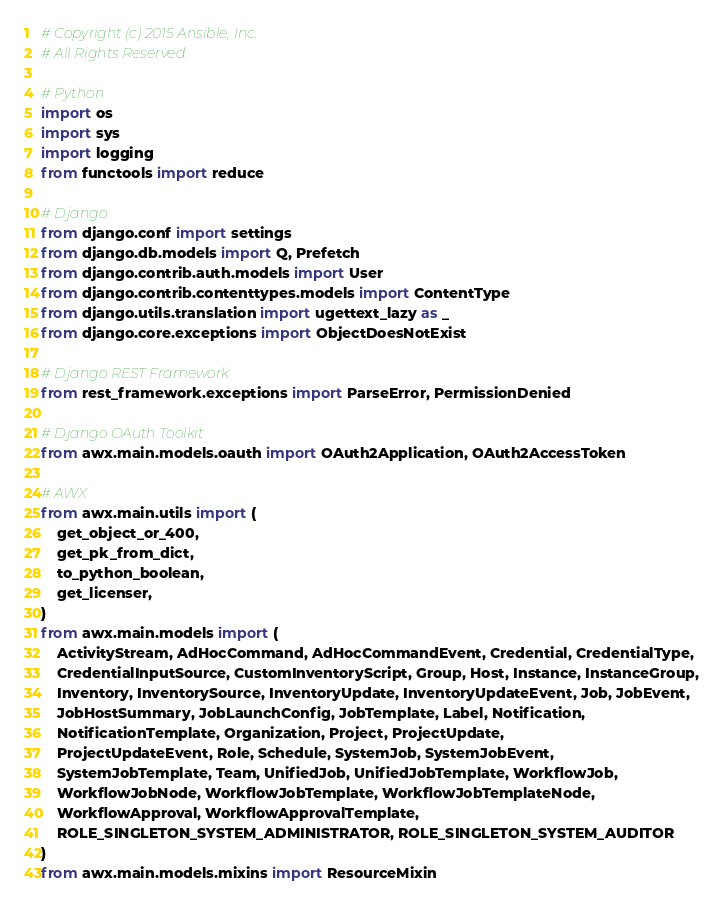Convert code to text. <code><loc_0><loc_0><loc_500><loc_500><_Python_># Copyright (c) 2015 Ansible, Inc.
# All Rights Reserved.

# Python
import os
import sys
import logging
from functools import reduce

# Django
from django.conf import settings
from django.db.models import Q, Prefetch
from django.contrib.auth.models import User
from django.contrib.contenttypes.models import ContentType
from django.utils.translation import ugettext_lazy as _
from django.core.exceptions import ObjectDoesNotExist

# Django REST Framework
from rest_framework.exceptions import ParseError, PermissionDenied

# Django OAuth Toolkit
from awx.main.models.oauth import OAuth2Application, OAuth2AccessToken

# AWX
from awx.main.utils import (
    get_object_or_400,
    get_pk_from_dict,
    to_python_boolean,
    get_licenser,
)
from awx.main.models import (
    ActivityStream, AdHocCommand, AdHocCommandEvent, Credential, CredentialType,
    CredentialInputSource, CustomInventoryScript, Group, Host, Instance, InstanceGroup,
    Inventory, InventorySource, InventoryUpdate, InventoryUpdateEvent, Job, JobEvent,
    JobHostSummary, JobLaunchConfig, JobTemplate, Label, Notification,
    NotificationTemplate, Organization, Project, ProjectUpdate,
    ProjectUpdateEvent, Role, Schedule, SystemJob, SystemJobEvent,
    SystemJobTemplate, Team, UnifiedJob, UnifiedJobTemplate, WorkflowJob,
    WorkflowJobNode, WorkflowJobTemplate, WorkflowJobTemplateNode,
    WorkflowApproval, WorkflowApprovalTemplate,
    ROLE_SINGLETON_SYSTEM_ADMINISTRATOR, ROLE_SINGLETON_SYSTEM_AUDITOR
)
from awx.main.models.mixins import ResourceMixin
</code> 